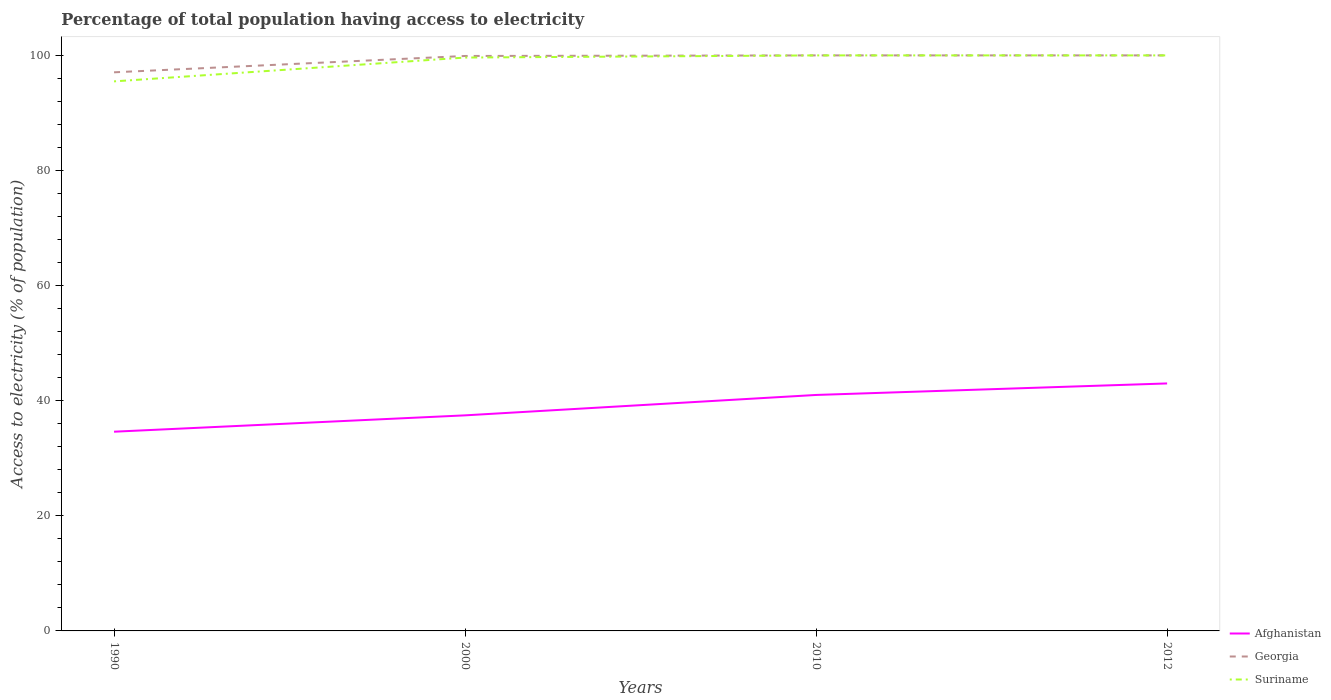How many different coloured lines are there?
Offer a very short reply. 3. Does the line corresponding to Georgia intersect with the line corresponding to Afghanistan?
Give a very brief answer. No. Is the number of lines equal to the number of legend labels?
Your answer should be compact. Yes. Across all years, what is the maximum percentage of population that have access to electricity in Suriname?
Make the answer very short. 95.49. In which year was the percentage of population that have access to electricity in Suriname maximum?
Your answer should be very brief. 1990. What is the total percentage of population that have access to electricity in Afghanistan in the graph?
Provide a short and direct response. -3.54. What is the difference between the highest and the second highest percentage of population that have access to electricity in Afghanistan?
Your answer should be very brief. 8.38. What is the difference between the highest and the lowest percentage of population that have access to electricity in Afghanistan?
Provide a succinct answer. 2. Is the percentage of population that have access to electricity in Georgia strictly greater than the percentage of population that have access to electricity in Suriname over the years?
Give a very brief answer. No. How many lines are there?
Give a very brief answer. 3. How many years are there in the graph?
Give a very brief answer. 4. What is the difference between two consecutive major ticks on the Y-axis?
Your answer should be very brief. 20. Are the values on the major ticks of Y-axis written in scientific E-notation?
Make the answer very short. No. How many legend labels are there?
Make the answer very short. 3. How are the legend labels stacked?
Provide a short and direct response. Vertical. What is the title of the graph?
Provide a short and direct response. Percentage of total population having access to electricity. What is the label or title of the X-axis?
Provide a succinct answer. Years. What is the label or title of the Y-axis?
Ensure brevity in your answer.  Access to electricity (% of population). What is the Access to electricity (% of population) of Afghanistan in 1990?
Offer a terse response. 34.62. What is the Access to electricity (% of population) in Georgia in 1990?
Provide a short and direct response. 97.06. What is the Access to electricity (% of population) of Suriname in 1990?
Your answer should be compact. 95.49. What is the Access to electricity (% of population) of Afghanistan in 2000?
Offer a terse response. 37.46. What is the Access to electricity (% of population) of Georgia in 2000?
Your response must be concise. 99.9. What is the Access to electricity (% of population) of Suriname in 2000?
Make the answer very short. 99.62. What is the Access to electricity (% of population) in Suriname in 2010?
Offer a terse response. 100. What is the Access to electricity (% of population) in Afghanistan in 2012?
Make the answer very short. 43. What is the Access to electricity (% of population) in Suriname in 2012?
Your answer should be compact. 100. Across all years, what is the maximum Access to electricity (% of population) of Suriname?
Give a very brief answer. 100. Across all years, what is the minimum Access to electricity (% of population) in Afghanistan?
Offer a terse response. 34.62. Across all years, what is the minimum Access to electricity (% of population) of Georgia?
Provide a succinct answer. 97.06. Across all years, what is the minimum Access to electricity (% of population) of Suriname?
Keep it short and to the point. 95.49. What is the total Access to electricity (% of population) of Afghanistan in the graph?
Offer a terse response. 156.07. What is the total Access to electricity (% of population) of Georgia in the graph?
Offer a terse response. 396.96. What is the total Access to electricity (% of population) in Suriname in the graph?
Keep it short and to the point. 395.11. What is the difference between the Access to electricity (% of population) of Afghanistan in 1990 and that in 2000?
Offer a very short reply. -2.84. What is the difference between the Access to electricity (% of population) in Georgia in 1990 and that in 2000?
Offer a terse response. -2.84. What is the difference between the Access to electricity (% of population) of Suriname in 1990 and that in 2000?
Provide a succinct answer. -4.14. What is the difference between the Access to electricity (% of population) in Afghanistan in 1990 and that in 2010?
Offer a very short reply. -6.38. What is the difference between the Access to electricity (% of population) in Georgia in 1990 and that in 2010?
Offer a terse response. -2.94. What is the difference between the Access to electricity (% of population) of Suriname in 1990 and that in 2010?
Give a very brief answer. -4.51. What is the difference between the Access to electricity (% of population) in Afghanistan in 1990 and that in 2012?
Give a very brief answer. -8.38. What is the difference between the Access to electricity (% of population) of Georgia in 1990 and that in 2012?
Ensure brevity in your answer.  -2.94. What is the difference between the Access to electricity (% of population) in Suriname in 1990 and that in 2012?
Provide a succinct answer. -4.51. What is the difference between the Access to electricity (% of population) in Afghanistan in 2000 and that in 2010?
Your answer should be compact. -3.54. What is the difference between the Access to electricity (% of population) of Suriname in 2000 and that in 2010?
Make the answer very short. -0.38. What is the difference between the Access to electricity (% of population) of Afghanistan in 2000 and that in 2012?
Your answer should be compact. -5.54. What is the difference between the Access to electricity (% of population) of Georgia in 2000 and that in 2012?
Ensure brevity in your answer.  -0.1. What is the difference between the Access to electricity (% of population) of Suriname in 2000 and that in 2012?
Your answer should be very brief. -0.38. What is the difference between the Access to electricity (% of population) of Afghanistan in 2010 and that in 2012?
Offer a very short reply. -2. What is the difference between the Access to electricity (% of population) in Georgia in 2010 and that in 2012?
Ensure brevity in your answer.  0. What is the difference between the Access to electricity (% of population) in Suriname in 2010 and that in 2012?
Provide a succinct answer. 0. What is the difference between the Access to electricity (% of population) in Afghanistan in 1990 and the Access to electricity (% of population) in Georgia in 2000?
Keep it short and to the point. -65.28. What is the difference between the Access to electricity (% of population) of Afghanistan in 1990 and the Access to electricity (% of population) of Suriname in 2000?
Offer a terse response. -65.01. What is the difference between the Access to electricity (% of population) in Georgia in 1990 and the Access to electricity (% of population) in Suriname in 2000?
Make the answer very short. -2.56. What is the difference between the Access to electricity (% of population) in Afghanistan in 1990 and the Access to electricity (% of population) in Georgia in 2010?
Provide a short and direct response. -65.38. What is the difference between the Access to electricity (% of population) of Afghanistan in 1990 and the Access to electricity (% of population) of Suriname in 2010?
Your answer should be compact. -65.38. What is the difference between the Access to electricity (% of population) of Georgia in 1990 and the Access to electricity (% of population) of Suriname in 2010?
Give a very brief answer. -2.94. What is the difference between the Access to electricity (% of population) in Afghanistan in 1990 and the Access to electricity (% of population) in Georgia in 2012?
Your answer should be very brief. -65.38. What is the difference between the Access to electricity (% of population) of Afghanistan in 1990 and the Access to electricity (% of population) of Suriname in 2012?
Provide a short and direct response. -65.38. What is the difference between the Access to electricity (% of population) of Georgia in 1990 and the Access to electricity (% of population) of Suriname in 2012?
Offer a terse response. -2.94. What is the difference between the Access to electricity (% of population) of Afghanistan in 2000 and the Access to electricity (% of population) of Georgia in 2010?
Make the answer very short. -62.54. What is the difference between the Access to electricity (% of population) of Afghanistan in 2000 and the Access to electricity (% of population) of Suriname in 2010?
Offer a very short reply. -62.54. What is the difference between the Access to electricity (% of population) in Afghanistan in 2000 and the Access to electricity (% of population) in Georgia in 2012?
Provide a succinct answer. -62.54. What is the difference between the Access to electricity (% of population) in Afghanistan in 2000 and the Access to electricity (% of population) in Suriname in 2012?
Your answer should be very brief. -62.54. What is the difference between the Access to electricity (% of population) of Afghanistan in 2010 and the Access to electricity (% of population) of Georgia in 2012?
Ensure brevity in your answer.  -59. What is the difference between the Access to electricity (% of population) of Afghanistan in 2010 and the Access to electricity (% of population) of Suriname in 2012?
Your answer should be compact. -59. What is the average Access to electricity (% of population) of Afghanistan per year?
Ensure brevity in your answer.  39.02. What is the average Access to electricity (% of population) of Georgia per year?
Provide a short and direct response. 99.24. What is the average Access to electricity (% of population) of Suriname per year?
Ensure brevity in your answer.  98.78. In the year 1990, what is the difference between the Access to electricity (% of population) in Afghanistan and Access to electricity (% of population) in Georgia?
Keep it short and to the point. -62.44. In the year 1990, what is the difference between the Access to electricity (% of population) of Afghanistan and Access to electricity (% of population) of Suriname?
Your answer should be compact. -60.87. In the year 1990, what is the difference between the Access to electricity (% of population) in Georgia and Access to electricity (% of population) in Suriname?
Offer a very short reply. 1.57. In the year 2000, what is the difference between the Access to electricity (% of population) in Afghanistan and Access to electricity (% of population) in Georgia?
Give a very brief answer. -62.44. In the year 2000, what is the difference between the Access to electricity (% of population) in Afghanistan and Access to electricity (% of population) in Suriname?
Offer a terse response. -62.17. In the year 2000, what is the difference between the Access to electricity (% of population) of Georgia and Access to electricity (% of population) of Suriname?
Keep it short and to the point. 0.28. In the year 2010, what is the difference between the Access to electricity (% of population) in Afghanistan and Access to electricity (% of population) in Georgia?
Keep it short and to the point. -59. In the year 2010, what is the difference between the Access to electricity (% of population) in Afghanistan and Access to electricity (% of population) in Suriname?
Give a very brief answer. -59. In the year 2010, what is the difference between the Access to electricity (% of population) of Georgia and Access to electricity (% of population) of Suriname?
Keep it short and to the point. 0. In the year 2012, what is the difference between the Access to electricity (% of population) in Afghanistan and Access to electricity (% of population) in Georgia?
Ensure brevity in your answer.  -57. In the year 2012, what is the difference between the Access to electricity (% of population) of Afghanistan and Access to electricity (% of population) of Suriname?
Ensure brevity in your answer.  -57. What is the ratio of the Access to electricity (% of population) of Afghanistan in 1990 to that in 2000?
Keep it short and to the point. 0.92. What is the ratio of the Access to electricity (% of population) in Georgia in 1990 to that in 2000?
Your answer should be compact. 0.97. What is the ratio of the Access to electricity (% of population) of Suriname in 1990 to that in 2000?
Provide a short and direct response. 0.96. What is the ratio of the Access to electricity (% of population) in Afghanistan in 1990 to that in 2010?
Provide a short and direct response. 0.84. What is the ratio of the Access to electricity (% of population) in Georgia in 1990 to that in 2010?
Provide a succinct answer. 0.97. What is the ratio of the Access to electricity (% of population) of Suriname in 1990 to that in 2010?
Give a very brief answer. 0.95. What is the ratio of the Access to electricity (% of population) of Afghanistan in 1990 to that in 2012?
Your answer should be compact. 0.81. What is the ratio of the Access to electricity (% of population) of Georgia in 1990 to that in 2012?
Your answer should be compact. 0.97. What is the ratio of the Access to electricity (% of population) of Suriname in 1990 to that in 2012?
Keep it short and to the point. 0.95. What is the ratio of the Access to electricity (% of population) of Afghanistan in 2000 to that in 2010?
Offer a terse response. 0.91. What is the ratio of the Access to electricity (% of population) of Georgia in 2000 to that in 2010?
Keep it short and to the point. 1. What is the ratio of the Access to electricity (% of population) of Suriname in 2000 to that in 2010?
Offer a very short reply. 1. What is the ratio of the Access to electricity (% of population) in Afghanistan in 2000 to that in 2012?
Provide a succinct answer. 0.87. What is the ratio of the Access to electricity (% of population) of Georgia in 2000 to that in 2012?
Provide a succinct answer. 1. What is the ratio of the Access to electricity (% of population) of Afghanistan in 2010 to that in 2012?
Provide a succinct answer. 0.95. What is the ratio of the Access to electricity (% of population) in Georgia in 2010 to that in 2012?
Provide a short and direct response. 1. What is the difference between the highest and the second highest Access to electricity (% of population) in Afghanistan?
Provide a short and direct response. 2. What is the difference between the highest and the second highest Access to electricity (% of population) of Georgia?
Provide a succinct answer. 0. What is the difference between the highest and the second highest Access to electricity (% of population) in Suriname?
Offer a terse response. 0. What is the difference between the highest and the lowest Access to electricity (% of population) in Afghanistan?
Give a very brief answer. 8.38. What is the difference between the highest and the lowest Access to electricity (% of population) in Georgia?
Provide a short and direct response. 2.94. What is the difference between the highest and the lowest Access to electricity (% of population) of Suriname?
Ensure brevity in your answer.  4.51. 